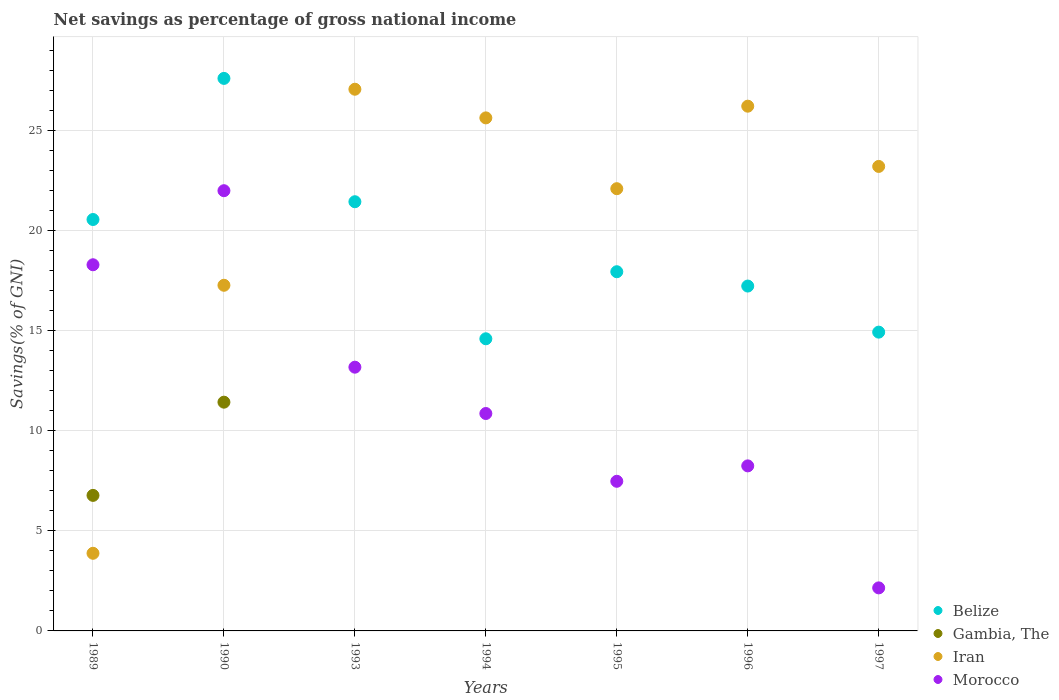What is the total savings in Gambia, The in 1994?
Your response must be concise. 0. Across all years, what is the maximum total savings in Gambia, The?
Provide a succinct answer. 11.43. Across all years, what is the minimum total savings in Morocco?
Make the answer very short. 2.15. What is the total total savings in Morocco in the graph?
Offer a terse response. 82.23. What is the difference between the total savings in Morocco in 1993 and that in 1995?
Provide a succinct answer. 5.7. What is the difference between the total savings in Morocco in 1993 and the total savings in Belize in 1994?
Make the answer very short. -1.42. What is the average total savings in Morocco per year?
Ensure brevity in your answer.  11.75. In the year 1993, what is the difference between the total savings in Iran and total savings in Morocco?
Your response must be concise. 13.89. What is the ratio of the total savings in Gambia, The in 1989 to that in 1990?
Keep it short and to the point. 0.59. Is the total savings in Belize in 1994 less than that in 1996?
Your answer should be very brief. Yes. What is the difference between the highest and the second highest total savings in Iran?
Your answer should be compact. 0.85. What is the difference between the highest and the lowest total savings in Gambia, The?
Offer a very short reply. 11.43. In how many years, is the total savings in Belize greater than the average total savings in Belize taken over all years?
Keep it short and to the point. 3. Is the sum of the total savings in Belize in 1995 and 1997 greater than the maximum total savings in Iran across all years?
Provide a succinct answer. Yes. Is it the case that in every year, the sum of the total savings in Iran and total savings in Gambia, The  is greater than the total savings in Morocco?
Give a very brief answer. No. Is the total savings in Belize strictly greater than the total savings in Gambia, The over the years?
Offer a terse response. Yes. Does the graph contain any zero values?
Ensure brevity in your answer.  Yes. Does the graph contain grids?
Ensure brevity in your answer.  Yes. How many legend labels are there?
Make the answer very short. 4. How are the legend labels stacked?
Your response must be concise. Vertical. What is the title of the graph?
Your answer should be very brief. Net savings as percentage of gross national income. What is the label or title of the X-axis?
Your answer should be very brief. Years. What is the label or title of the Y-axis?
Your response must be concise. Savings(% of GNI). What is the Savings(% of GNI) of Belize in 1989?
Offer a terse response. 20.56. What is the Savings(% of GNI) in Gambia, The in 1989?
Provide a succinct answer. 6.77. What is the Savings(% of GNI) of Iran in 1989?
Offer a very short reply. 3.88. What is the Savings(% of GNI) in Morocco in 1989?
Your answer should be very brief. 18.3. What is the Savings(% of GNI) in Belize in 1990?
Give a very brief answer. 27.61. What is the Savings(% of GNI) of Gambia, The in 1990?
Ensure brevity in your answer.  11.43. What is the Savings(% of GNI) of Iran in 1990?
Your answer should be very brief. 17.28. What is the Savings(% of GNI) of Morocco in 1990?
Your answer should be very brief. 22. What is the Savings(% of GNI) of Belize in 1993?
Ensure brevity in your answer.  21.45. What is the Savings(% of GNI) in Gambia, The in 1993?
Provide a short and direct response. 0. What is the Savings(% of GNI) of Iran in 1993?
Offer a terse response. 27.07. What is the Savings(% of GNI) of Morocco in 1993?
Provide a succinct answer. 13.18. What is the Savings(% of GNI) of Belize in 1994?
Your answer should be very brief. 14.6. What is the Savings(% of GNI) in Gambia, The in 1994?
Ensure brevity in your answer.  0. What is the Savings(% of GNI) in Iran in 1994?
Ensure brevity in your answer.  25.64. What is the Savings(% of GNI) of Morocco in 1994?
Your answer should be compact. 10.87. What is the Savings(% of GNI) of Belize in 1995?
Your response must be concise. 17.95. What is the Savings(% of GNI) of Iran in 1995?
Your answer should be very brief. 22.1. What is the Savings(% of GNI) in Morocco in 1995?
Provide a short and direct response. 7.48. What is the Savings(% of GNI) of Belize in 1996?
Offer a terse response. 17.24. What is the Savings(% of GNI) of Gambia, The in 1996?
Make the answer very short. 0. What is the Savings(% of GNI) in Iran in 1996?
Provide a short and direct response. 26.23. What is the Savings(% of GNI) of Morocco in 1996?
Provide a succinct answer. 8.25. What is the Savings(% of GNI) of Belize in 1997?
Give a very brief answer. 14.93. What is the Savings(% of GNI) in Gambia, The in 1997?
Your answer should be compact. 0. What is the Savings(% of GNI) of Iran in 1997?
Your answer should be compact. 23.21. What is the Savings(% of GNI) in Morocco in 1997?
Provide a succinct answer. 2.15. Across all years, what is the maximum Savings(% of GNI) in Belize?
Offer a very short reply. 27.61. Across all years, what is the maximum Savings(% of GNI) of Gambia, The?
Keep it short and to the point. 11.43. Across all years, what is the maximum Savings(% of GNI) in Iran?
Your response must be concise. 27.07. Across all years, what is the maximum Savings(% of GNI) of Morocco?
Give a very brief answer. 22. Across all years, what is the minimum Savings(% of GNI) in Belize?
Give a very brief answer. 14.6. Across all years, what is the minimum Savings(% of GNI) of Iran?
Keep it short and to the point. 3.88. Across all years, what is the minimum Savings(% of GNI) in Morocco?
Provide a succinct answer. 2.15. What is the total Savings(% of GNI) of Belize in the graph?
Provide a short and direct response. 134.35. What is the total Savings(% of GNI) in Gambia, The in the graph?
Your response must be concise. 18.21. What is the total Savings(% of GNI) in Iran in the graph?
Your answer should be compact. 145.41. What is the total Savings(% of GNI) of Morocco in the graph?
Offer a very short reply. 82.23. What is the difference between the Savings(% of GNI) of Belize in 1989 and that in 1990?
Give a very brief answer. -7.05. What is the difference between the Savings(% of GNI) of Gambia, The in 1989 and that in 1990?
Give a very brief answer. -4.66. What is the difference between the Savings(% of GNI) in Iran in 1989 and that in 1990?
Make the answer very short. -13.4. What is the difference between the Savings(% of GNI) in Morocco in 1989 and that in 1990?
Provide a succinct answer. -3.7. What is the difference between the Savings(% of GNI) of Belize in 1989 and that in 1993?
Ensure brevity in your answer.  -0.89. What is the difference between the Savings(% of GNI) in Iran in 1989 and that in 1993?
Make the answer very short. -23.19. What is the difference between the Savings(% of GNI) in Morocco in 1989 and that in 1993?
Your response must be concise. 5.12. What is the difference between the Savings(% of GNI) in Belize in 1989 and that in 1994?
Your answer should be compact. 5.96. What is the difference between the Savings(% of GNI) in Iran in 1989 and that in 1994?
Give a very brief answer. -21.76. What is the difference between the Savings(% of GNI) of Morocco in 1989 and that in 1994?
Keep it short and to the point. 7.43. What is the difference between the Savings(% of GNI) of Belize in 1989 and that in 1995?
Offer a terse response. 2.61. What is the difference between the Savings(% of GNI) of Iran in 1989 and that in 1995?
Offer a very short reply. -18.22. What is the difference between the Savings(% of GNI) of Morocco in 1989 and that in 1995?
Ensure brevity in your answer.  10.82. What is the difference between the Savings(% of GNI) in Belize in 1989 and that in 1996?
Make the answer very short. 3.33. What is the difference between the Savings(% of GNI) of Iran in 1989 and that in 1996?
Your response must be concise. -22.35. What is the difference between the Savings(% of GNI) in Morocco in 1989 and that in 1996?
Your response must be concise. 10.05. What is the difference between the Savings(% of GNI) of Belize in 1989 and that in 1997?
Offer a terse response. 5.63. What is the difference between the Savings(% of GNI) in Iran in 1989 and that in 1997?
Make the answer very short. -19.34. What is the difference between the Savings(% of GNI) in Morocco in 1989 and that in 1997?
Provide a short and direct response. 16.15. What is the difference between the Savings(% of GNI) in Belize in 1990 and that in 1993?
Ensure brevity in your answer.  6.16. What is the difference between the Savings(% of GNI) in Iran in 1990 and that in 1993?
Give a very brief answer. -9.8. What is the difference between the Savings(% of GNI) in Morocco in 1990 and that in 1993?
Your answer should be compact. 8.82. What is the difference between the Savings(% of GNI) in Belize in 1990 and that in 1994?
Provide a short and direct response. 13.01. What is the difference between the Savings(% of GNI) of Iran in 1990 and that in 1994?
Ensure brevity in your answer.  -8.37. What is the difference between the Savings(% of GNI) of Morocco in 1990 and that in 1994?
Your answer should be very brief. 11.14. What is the difference between the Savings(% of GNI) of Belize in 1990 and that in 1995?
Keep it short and to the point. 9.66. What is the difference between the Savings(% of GNI) in Iran in 1990 and that in 1995?
Provide a succinct answer. -4.83. What is the difference between the Savings(% of GNI) in Morocco in 1990 and that in 1995?
Keep it short and to the point. 14.52. What is the difference between the Savings(% of GNI) in Belize in 1990 and that in 1996?
Offer a terse response. 10.38. What is the difference between the Savings(% of GNI) of Iran in 1990 and that in 1996?
Give a very brief answer. -8.95. What is the difference between the Savings(% of GNI) in Morocco in 1990 and that in 1996?
Offer a terse response. 13.75. What is the difference between the Savings(% of GNI) in Belize in 1990 and that in 1997?
Offer a very short reply. 12.68. What is the difference between the Savings(% of GNI) in Iran in 1990 and that in 1997?
Your answer should be very brief. -5.94. What is the difference between the Savings(% of GNI) of Morocco in 1990 and that in 1997?
Give a very brief answer. 19.85. What is the difference between the Savings(% of GNI) of Belize in 1993 and that in 1994?
Your answer should be very brief. 6.85. What is the difference between the Savings(% of GNI) of Iran in 1993 and that in 1994?
Offer a terse response. 1.43. What is the difference between the Savings(% of GNI) of Morocco in 1993 and that in 1994?
Offer a very short reply. 2.32. What is the difference between the Savings(% of GNI) in Belize in 1993 and that in 1995?
Offer a terse response. 3.5. What is the difference between the Savings(% of GNI) in Iran in 1993 and that in 1995?
Make the answer very short. 4.97. What is the difference between the Savings(% of GNI) in Morocco in 1993 and that in 1995?
Offer a very short reply. 5.7. What is the difference between the Savings(% of GNI) of Belize in 1993 and that in 1996?
Your answer should be very brief. 4.21. What is the difference between the Savings(% of GNI) of Iran in 1993 and that in 1996?
Give a very brief answer. 0.85. What is the difference between the Savings(% of GNI) of Morocco in 1993 and that in 1996?
Give a very brief answer. 4.93. What is the difference between the Savings(% of GNI) in Belize in 1993 and that in 1997?
Your answer should be compact. 6.52. What is the difference between the Savings(% of GNI) of Iran in 1993 and that in 1997?
Ensure brevity in your answer.  3.86. What is the difference between the Savings(% of GNI) of Morocco in 1993 and that in 1997?
Your answer should be very brief. 11.03. What is the difference between the Savings(% of GNI) in Belize in 1994 and that in 1995?
Offer a terse response. -3.35. What is the difference between the Savings(% of GNI) in Iran in 1994 and that in 1995?
Keep it short and to the point. 3.54. What is the difference between the Savings(% of GNI) in Morocco in 1994 and that in 1995?
Ensure brevity in your answer.  3.39. What is the difference between the Savings(% of GNI) in Belize in 1994 and that in 1996?
Your answer should be very brief. -2.64. What is the difference between the Savings(% of GNI) of Iran in 1994 and that in 1996?
Your answer should be compact. -0.58. What is the difference between the Savings(% of GNI) in Morocco in 1994 and that in 1996?
Your answer should be compact. 2.62. What is the difference between the Savings(% of GNI) in Belize in 1994 and that in 1997?
Ensure brevity in your answer.  -0.33. What is the difference between the Savings(% of GNI) of Iran in 1994 and that in 1997?
Your answer should be very brief. 2.43. What is the difference between the Savings(% of GNI) of Morocco in 1994 and that in 1997?
Your response must be concise. 8.71. What is the difference between the Savings(% of GNI) of Belize in 1995 and that in 1996?
Ensure brevity in your answer.  0.72. What is the difference between the Savings(% of GNI) of Iran in 1995 and that in 1996?
Make the answer very short. -4.12. What is the difference between the Savings(% of GNI) in Morocco in 1995 and that in 1996?
Your response must be concise. -0.77. What is the difference between the Savings(% of GNI) of Belize in 1995 and that in 1997?
Ensure brevity in your answer.  3.02. What is the difference between the Savings(% of GNI) in Iran in 1995 and that in 1997?
Offer a very short reply. -1.11. What is the difference between the Savings(% of GNI) in Morocco in 1995 and that in 1997?
Give a very brief answer. 5.33. What is the difference between the Savings(% of GNI) of Belize in 1996 and that in 1997?
Provide a succinct answer. 2.3. What is the difference between the Savings(% of GNI) in Iran in 1996 and that in 1997?
Ensure brevity in your answer.  3.01. What is the difference between the Savings(% of GNI) in Morocco in 1996 and that in 1997?
Your response must be concise. 6.1. What is the difference between the Savings(% of GNI) of Belize in 1989 and the Savings(% of GNI) of Gambia, The in 1990?
Offer a very short reply. 9.13. What is the difference between the Savings(% of GNI) in Belize in 1989 and the Savings(% of GNI) in Iran in 1990?
Offer a terse response. 3.29. What is the difference between the Savings(% of GNI) of Belize in 1989 and the Savings(% of GNI) of Morocco in 1990?
Give a very brief answer. -1.44. What is the difference between the Savings(% of GNI) in Gambia, The in 1989 and the Savings(% of GNI) in Iran in 1990?
Keep it short and to the point. -10.5. What is the difference between the Savings(% of GNI) in Gambia, The in 1989 and the Savings(% of GNI) in Morocco in 1990?
Keep it short and to the point. -15.23. What is the difference between the Savings(% of GNI) in Iran in 1989 and the Savings(% of GNI) in Morocco in 1990?
Your response must be concise. -18.12. What is the difference between the Savings(% of GNI) in Belize in 1989 and the Savings(% of GNI) in Iran in 1993?
Provide a succinct answer. -6.51. What is the difference between the Savings(% of GNI) in Belize in 1989 and the Savings(% of GNI) in Morocco in 1993?
Give a very brief answer. 7.38. What is the difference between the Savings(% of GNI) in Gambia, The in 1989 and the Savings(% of GNI) in Iran in 1993?
Your answer should be compact. -20.3. What is the difference between the Savings(% of GNI) in Gambia, The in 1989 and the Savings(% of GNI) in Morocco in 1993?
Give a very brief answer. -6.41. What is the difference between the Savings(% of GNI) in Iran in 1989 and the Savings(% of GNI) in Morocco in 1993?
Offer a terse response. -9.3. What is the difference between the Savings(% of GNI) of Belize in 1989 and the Savings(% of GNI) of Iran in 1994?
Provide a short and direct response. -5.08. What is the difference between the Savings(% of GNI) in Belize in 1989 and the Savings(% of GNI) in Morocco in 1994?
Ensure brevity in your answer.  9.7. What is the difference between the Savings(% of GNI) in Gambia, The in 1989 and the Savings(% of GNI) in Iran in 1994?
Make the answer very short. -18.87. What is the difference between the Savings(% of GNI) in Gambia, The in 1989 and the Savings(% of GNI) in Morocco in 1994?
Provide a succinct answer. -4.09. What is the difference between the Savings(% of GNI) of Iran in 1989 and the Savings(% of GNI) of Morocco in 1994?
Your response must be concise. -6.99. What is the difference between the Savings(% of GNI) of Belize in 1989 and the Savings(% of GNI) of Iran in 1995?
Your response must be concise. -1.54. What is the difference between the Savings(% of GNI) in Belize in 1989 and the Savings(% of GNI) in Morocco in 1995?
Give a very brief answer. 13.08. What is the difference between the Savings(% of GNI) in Gambia, The in 1989 and the Savings(% of GNI) in Iran in 1995?
Provide a succinct answer. -15.33. What is the difference between the Savings(% of GNI) in Gambia, The in 1989 and the Savings(% of GNI) in Morocco in 1995?
Provide a succinct answer. -0.7. What is the difference between the Savings(% of GNI) in Iran in 1989 and the Savings(% of GNI) in Morocco in 1995?
Give a very brief answer. -3.6. What is the difference between the Savings(% of GNI) of Belize in 1989 and the Savings(% of GNI) of Iran in 1996?
Make the answer very short. -5.66. What is the difference between the Savings(% of GNI) of Belize in 1989 and the Savings(% of GNI) of Morocco in 1996?
Your answer should be very brief. 12.31. What is the difference between the Savings(% of GNI) of Gambia, The in 1989 and the Savings(% of GNI) of Iran in 1996?
Your response must be concise. -19.45. What is the difference between the Savings(% of GNI) in Gambia, The in 1989 and the Savings(% of GNI) in Morocco in 1996?
Your response must be concise. -1.47. What is the difference between the Savings(% of GNI) in Iran in 1989 and the Savings(% of GNI) in Morocco in 1996?
Keep it short and to the point. -4.37. What is the difference between the Savings(% of GNI) in Belize in 1989 and the Savings(% of GNI) in Iran in 1997?
Offer a very short reply. -2.65. What is the difference between the Savings(% of GNI) in Belize in 1989 and the Savings(% of GNI) in Morocco in 1997?
Make the answer very short. 18.41. What is the difference between the Savings(% of GNI) in Gambia, The in 1989 and the Savings(% of GNI) in Iran in 1997?
Provide a short and direct response. -16.44. What is the difference between the Savings(% of GNI) of Gambia, The in 1989 and the Savings(% of GNI) of Morocco in 1997?
Your response must be concise. 4.62. What is the difference between the Savings(% of GNI) of Iran in 1989 and the Savings(% of GNI) of Morocco in 1997?
Give a very brief answer. 1.73. What is the difference between the Savings(% of GNI) of Belize in 1990 and the Savings(% of GNI) of Iran in 1993?
Your answer should be very brief. 0.54. What is the difference between the Savings(% of GNI) of Belize in 1990 and the Savings(% of GNI) of Morocco in 1993?
Provide a short and direct response. 14.43. What is the difference between the Savings(% of GNI) in Gambia, The in 1990 and the Savings(% of GNI) in Iran in 1993?
Offer a very short reply. -15.64. What is the difference between the Savings(% of GNI) of Gambia, The in 1990 and the Savings(% of GNI) of Morocco in 1993?
Provide a short and direct response. -1.75. What is the difference between the Savings(% of GNI) of Iran in 1990 and the Savings(% of GNI) of Morocco in 1993?
Give a very brief answer. 4.09. What is the difference between the Savings(% of GNI) in Belize in 1990 and the Savings(% of GNI) in Iran in 1994?
Keep it short and to the point. 1.97. What is the difference between the Savings(% of GNI) in Belize in 1990 and the Savings(% of GNI) in Morocco in 1994?
Your response must be concise. 16.75. What is the difference between the Savings(% of GNI) in Gambia, The in 1990 and the Savings(% of GNI) in Iran in 1994?
Your answer should be very brief. -14.21. What is the difference between the Savings(% of GNI) of Gambia, The in 1990 and the Savings(% of GNI) of Morocco in 1994?
Offer a very short reply. 0.57. What is the difference between the Savings(% of GNI) in Iran in 1990 and the Savings(% of GNI) in Morocco in 1994?
Your response must be concise. 6.41. What is the difference between the Savings(% of GNI) in Belize in 1990 and the Savings(% of GNI) in Iran in 1995?
Your response must be concise. 5.51. What is the difference between the Savings(% of GNI) in Belize in 1990 and the Savings(% of GNI) in Morocco in 1995?
Provide a short and direct response. 20.14. What is the difference between the Savings(% of GNI) of Gambia, The in 1990 and the Savings(% of GNI) of Iran in 1995?
Make the answer very short. -10.67. What is the difference between the Savings(% of GNI) in Gambia, The in 1990 and the Savings(% of GNI) in Morocco in 1995?
Provide a short and direct response. 3.95. What is the difference between the Savings(% of GNI) of Iran in 1990 and the Savings(% of GNI) of Morocco in 1995?
Offer a very short reply. 9.8. What is the difference between the Savings(% of GNI) of Belize in 1990 and the Savings(% of GNI) of Iran in 1996?
Make the answer very short. 1.39. What is the difference between the Savings(% of GNI) in Belize in 1990 and the Savings(% of GNI) in Morocco in 1996?
Your answer should be very brief. 19.37. What is the difference between the Savings(% of GNI) in Gambia, The in 1990 and the Savings(% of GNI) in Iran in 1996?
Your answer should be very brief. -14.79. What is the difference between the Savings(% of GNI) of Gambia, The in 1990 and the Savings(% of GNI) of Morocco in 1996?
Make the answer very short. 3.18. What is the difference between the Savings(% of GNI) of Iran in 1990 and the Savings(% of GNI) of Morocco in 1996?
Offer a terse response. 9.03. What is the difference between the Savings(% of GNI) of Belize in 1990 and the Savings(% of GNI) of Iran in 1997?
Make the answer very short. 4.4. What is the difference between the Savings(% of GNI) of Belize in 1990 and the Savings(% of GNI) of Morocco in 1997?
Ensure brevity in your answer.  25.46. What is the difference between the Savings(% of GNI) of Gambia, The in 1990 and the Savings(% of GNI) of Iran in 1997?
Your answer should be very brief. -11.78. What is the difference between the Savings(% of GNI) in Gambia, The in 1990 and the Savings(% of GNI) in Morocco in 1997?
Your answer should be compact. 9.28. What is the difference between the Savings(% of GNI) of Iran in 1990 and the Savings(% of GNI) of Morocco in 1997?
Offer a very short reply. 15.12. What is the difference between the Savings(% of GNI) of Belize in 1993 and the Savings(% of GNI) of Iran in 1994?
Your answer should be very brief. -4.19. What is the difference between the Savings(% of GNI) in Belize in 1993 and the Savings(% of GNI) in Morocco in 1994?
Offer a very short reply. 10.58. What is the difference between the Savings(% of GNI) of Iran in 1993 and the Savings(% of GNI) of Morocco in 1994?
Give a very brief answer. 16.21. What is the difference between the Savings(% of GNI) in Belize in 1993 and the Savings(% of GNI) in Iran in 1995?
Give a very brief answer. -0.65. What is the difference between the Savings(% of GNI) of Belize in 1993 and the Savings(% of GNI) of Morocco in 1995?
Offer a terse response. 13.97. What is the difference between the Savings(% of GNI) of Iran in 1993 and the Savings(% of GNI) of Morocco in 1995?
Provide a short and direct response. 19.59. What is the difference between the Savings(% of GNI) in Belize in 1993 and the Savings(% of GNI) in Iran in 1996?
Keep it short and to the point. -4.78. What is the difference between the Savings(% of GNI) of Belize in 1993 and the Savings(% of GNI) of Morocco in 1996?
Ensure brevity in your answer.  13.2. What is the difference between the Savings(% of GNI) of Iran in 1993 and the Savings(% of GNI) of Morocco in 1996?
Ensure brevity in your answer.  18.82. What is the difference between the Savings(% of GNI) of Belize in 1993 and the Savings(% of GNI) of Iran in 1997?
Keep it short and to the point. -1.76. What is the difference between the Savings(% of GNI) in Belize in 1993 and the Savings(% of GNI) in Morocco in 1997?
Give a very brief answer. 19.3. What is the difference between the Savings(% of GNI) in Iran in 1993 and the Savings(% of GNI) in Morocco in 1997?
Provide a short and direct response. 24.92. What is the difference between the Savings(% of GNI) of Belize in 1994 and the Savings(% of GNI) of Iran in 1995?
Your answer should be very brief. -7.5. What is the difference between the Savings(% of GNI) in Belize in 1994 and the Savings(% of GNI) in Morocco in 1995?
Ensure brevity in your answer.  7.12. What is the difference between the Savings(% of GNI) in Iran in 1994 and the Savings(% of GNI) in Morocco in 1995?
Your response must be concise. 18.16. What is the difference between the Savings(% of GNI) in Belize in 1994 and the Savings(% of GNI) in Iran in 1996?
Keep it short and to the point. -11.63. What is the difference between the Savings(% of GNI) of Belize in 1994 and the Savings(% of GNI) of Morocco in 1996?
Offer a terse response. 6.35. What is the difference between the Savings(% of GNI) in Iran in 1994 and the Savings(% of GNI) in Morocco in 1996?
Your response must be concise. 17.39. What is the difference between the Savings(% of GNI) in Belize in 1994 and the Savings(% of GNI) in Iran in 1997?
Ensure brevity in your answer.  -8.61. What is the difference between the Savings(% of GNI) in Belize in 1994 and the Savings(% of GNI) in Morocco in 1997?
Ensure brevity in your answer.  12.45. What is the difference between the Savings(% of GNI) of Iran in 1994 and the Savings(% of GNI) of Morocco in 1997?
Give a very brief answer. 23.49. What is the difference between the Savings(% of GNI) of Belize in 1995 and the Savings(% of GNI) of Iran in 1996?
Provide a short and direct response. -8.27. What is the difference between the Savings(% of GNI) in Belize in 1995 and the Savings(% of GNI) in Morocco in 1996?
Give a very brief answer. 9.7. What is the difference between the Savings(% of GNI) of Iran in 1995 and the Savings(% of GNI) of Morocco in 1996?
Give a very brief answer. 13.85. What is the difference between the Savings(% of GNI) in Belize in 1995 and the Savings(% of GNI) in Iran in 1997?
Offer a very short reply. -5.26. What is the difference between the Savings(% of GNI) of Belize in 1995 and the Savings(% of GNI) of Morocco in 1997?
Your answer should be very brief. 15.8. What is the difference between the Savings(% of GNI) in Iran in 1995 and the Savings(% of GNI) in Morocco in 1997?
Provide a short and direct response. 19.95. What is the difference between the Savings(% of GNI) in Belize in 1996 and the Savings(% of GNI) in Iran in 1997?
Ensure brevity in your answer.  -5.98. What is the difference between the Savings(% of GNI) in Belize in 1996 and the Savings(% of GNI) in Morocco in 1997?
Ensure brevity in your answer.  15.09. What is the difference between the Savings(% of GNI) of Iran in 1996 and the Savings(% of GNI) of Morocco in 1997?
Your answer should be compact. 24.07. What is the average Savings(% of GNI) of Belize per year?
Provide a short and direct response. 19.19. What is the average Savings(% of GNI) in Gambia, The per year?
Provide a succinct answer. 2.6. What is the average Savings(% of GNI) in Iran per year?
Provide a succinct answer. 20.77. What is the average Savings(% of GNI) of Morocco per year?
Give a very brief answer. 11.75. In the year 1989, what is the difference between the Savings(% of GNI) of Belize and Savings(% of GNI) of Gambia, The?
Offer a very short reply. 13.79. In the year 1989, what is the difference between the Savings(% of GNI) in Belize and Savings(% of GNI) in Iran?
Provide a short and direct response. 16.68. In the year 1989, what is the difference between the Savings(% of GNI) of Belize and Savings(% of GNI) of Morocco?
Your response must be concise. 2.26. In the year 1989, what is the difference between the Savings(% of GNI) of Gambia, The and Savings(% of GNI) of Iran?
Your answer should be compact. 2.89. In the year 1989, what is the difference between the Savings(% of GNI) in Gambia, The and Savings(% of GNI) in Morocco?
Your answer should be very brief. -11.53. In the year 1989, what is the difference between the Savings(% of GNI) in Iran and Savings(% of GNI) in Morocco?
Your answer should be very brief. -14.42. In the year 1990, what is the difference between the Savings(% of GNI) in Belize and Savings(% of GNI) in Gambia, The?
Offer a terse response. 16.18. In the year 1990, what is the difference between the Savings(% of GNI) of Belize and Savings(% of GNI) of Iran?
Provide a short and direct response. 10.34. In the year 1990, what is the difference between the Savings(% of GNI) of Belize and Savings(% of GNI) of Morocco?
Keep it short and to the point. 5.61. In the year 1990, what is the difference between the Savings(% of GNI) of Gambia, The and Savings(% of GNI) of Iran?
Your response must be concise. -5.84. In the year 1990, what is the difference between the Savings(% of GNI) in Gambia, The and Savings(% of GNI) in Morocco?
Provide a succinct answer. -10.57. In the year 1990, what is the difference between the Savings(% of GNI) in Iran and Savings(% of GNI) in Morocco?
Keep it short and to the point. -4.73. In the year 1993, what is the difference between the Savings(% of GNI) in Belize and Savings(% of GNI) in Iran?
Keep it short and to the point. -5.62. In the year 1993, what is the difference between the Savings(% of GNI) of Belize and Savings(% of GNI) of Morocco?
Keep it short and to the point. 8.27. In the year 1993, what is the difference between the Savings(% of GNI) in Iran and Savings(% of GNI) in Morocco?
Your answer should be compact. 13.89. In the year 1994, what is the difference between the Savings(% of GNI) in Belize and Savings(% of GNI) in Iran?
Provide a succinct answer. -11.04. In the year 1994, what is the difference between the Savings(% of GNI) in Belize and Savings(% of GNI) in Morocco?
Ensure brevity in your answer.  3.73. In the year 1994, what is the difference between the Savings(% of GNI) of Iran and Savings(% of GNI) of Morocco?
Your answer should be very brief. 14.78. In the year 1995, what is the difference between the Savings(% of GNI) of Belize and Savings(% of GNI) of Iran?
Your response must be concise. -4.15. In the year 1995, what is the difference between the Savings(% of GNI) of Belize and Savings(% of GNI) of Morocco?
Offer a terse response. 10.47. In the year 1995, what is the difference between the Savings(% of GNI) of Iran and Savings(% of GNI) of Morocco?
Provide a short and direct response. 14.62. In the year 1996, what is the difference between the Savings(% of GNI) in Belize and Savings(% of GNI) in Iran?
Offer a very short reply. -8.99. In the year 1996, what is the difference between the Savings(% of GNI) in Belize and Savings(% of GNI) in Morocco?
Your response must be concise. 8.99. In the year 1996, what is the difference between the Savings(% of GNI) of Iran and Savings(% of GNI) of Morocco?
Make the answer very short. 17.98. In the year 1997, what is the difference between the Savings(% of GNI) in Belize and Savings(% of GNI) in Iran?
Keep it short and to the point. -8.28. In the year 1997, what is the difference between the Savings(% of GNI) of Belize and Savings(% of GNI) of Morocco?
Keep it short and to the point. 12.78. In the year 1997, what is the difference between the Savings(% of GNI) of Iran and Savings(% of GNI) of Morocco?
Offer a very short reply. 21.06. What is the ratio of the Savings(% of GNI) in Belize in 1989 to that in 1990?
Your response must be concise. 0.74. What is the ratio of the Savings(% of GNI) in Gambia, The in 1989 to that in 1990?
Offer a terse response. 0.59. What is the ratio of the Savings(% of GNI) of Iran in 1989 to that in 1990?
Provide a succinct answer. 0.22. What is the ratio of the Savings(% of GNI) of Morocco in 1989 to that in 1990?
Offer a very short reply. 0.83. What is the ratio of the Savings(% of GNI) in Belize in 1989 to that in 1993?
Your answer should be very brief. 0.96. What is the ratio of the Savings(% of GNI) in Iran in 1989 to that in 1993?
Your answer should be compact. 0.14. What is the ratio of the Savings(% of GNI) of Morocco in 1989 to that in 1993?
Offer a very short reply. 1.39. What is the ratio of the Savings(% of GNI) in Belize in 1989 to that in 1994?
Ensure brevity in your answer.  1.41. What is the ratio of the Savings(% of GNI) of Iran in 1989 to that in 1994?
Provide a succinct answer. 0.15. What is the ratio of the Savings(% of GNI) of Morocco in 1989 to that in 1994?
Ensure brevity in your answer.  1.68. What is the ratio of the Savings(% of GNI) of Belize in 1989 to that in 1995?
Keep it short and to the point. 1.15. What is the ratio of the Savings(% of GNI) in Iran in 1989 to that in 1995?
Offer a very short reply. 0.18. What is the ratio of the Savings(% of GNI) of Morocco in 1989 to that in 1995?
Your response must be concise. 2.45. What is the ratio of the Savings(% of GNI) in Belize in 1989 to that in 1996?
Offer a terse response. 1.19. What is the ratio of the Savings(% of GNI) of Iran in 1989 to that in 1996?
Your response must be concise. 0.15. What is the ratio of the Savings(% of GNI) of Morocco in 1989 to that in 1996?
Your answer should be very brief. 2.22. What is the ratio of the Savings(% of GNI) of Belize in 1989 to that in 1997?
Your answer should be compact. 1.38. What is the ratio of the Savings(% of GNI) of Iran in 1989 to that in 1997?
Keep it short and to the point. 0.17. What is the ratio of the Savings(% of GNI) in Morocco in 1989 to that in 1997?
Give a very brief answer. 8.51. What is the ratio of the Savings(% of GNI) in Belize in 1990 to that in 1993?
Your response must be concise. 1.29. What is the ratio of the Savings(% of GNI) of Iran in 1990 to that in 1993?
Ensure brevity in your answer.  0.64. What is the ratio of the Savings(% of GNI) in Morocco in 1990 to that in 1993?
Make the answer very short. 1.67. What is the ratio of the Savings(% of GNI) in Belize in 1990 to that in 1994?
Offer a terse response. 1.89. What is the ratio of the Savings(% of GNI) in Iran in 1990 to that in 1994?
Offer a very short reply. 0.67. What is the ratio of the Savings(% of GNI) of Morocco in 1990 to that in 1994?
Keep it short and to the point. 2.02. What is the ratio of the Savings(% of GNI) of Belize in 1990 to that in 1995?
Ensure brevity in your answer.  1.54. What is the ratio of the Savings(% of GNI) in Iran in 1990 to that in 1995?
Your response must be concise. 0.78. What is the ratio of the Savings(% of GNI) in Morocco in 1990 to that in 1995?
Ensure brevity in your answer.  2.94. What is the ratio of the Savings(% of GNI) of Belize in 1990 to that in 1996?
Your response must be concise. 1.6. What is the ratio of the Savings(% of GNI) in Iran in 1990 to that in 1996?
Offer a terse response. 0.66. What is the ratio of the Savings(% of GNI) in Morocco in 1990 to that in 1996?
Make the answer very short. 2.67. What is the ratio of the Savings(% of GNI) of Belize in 1990 to that in 1997?
Give a very brief answer. 1.85. What is the ratio of the Savings(% of GNI) of Iran in 1990 to that in 1997?
Provide a short and direct response. 0.74. What is the ratio of the Savings(% of GNI) of Morocco in 1990 to that in 1997?
Give a very brief answer. 10.23. What is the ratio of the Savings(% of GNI) of Belize in 1993 to that in 1994?
Offer a very short reply. 1.47. What is the ratio of the Savings(% of GNI) of Iran in 1993 to that in 1994?
Your response must be concise. 1.06. What is the ratio of the Savings(% of GNI) in Morocco in 1993 to that in 1994?
Provide a short and direct response. 1.21. What is the ratio of the Savings(% of GNI) in Belize in 1993 to that in 1995?
Ensure brevity in your answer.  1.19. What is the ratio of the Savings(% of GNI) of Iran in 1993 to that in 1995?
Your answer should be compact. 1.22. What is the ratio of the Savings(% of GNI) of Morocco in 1993 to that in 1995?
Give a very brief answer. 1.76. What is the ratio of the Savings(% of GNI) of Belize in 1993 to that in 1996?
Provide a short and direct response. 1.24. What is the ratio of the Savings(% of GNI) of Iran in 1993 to that in 1996?
Ensure brevity in your answer.  1.03. What is the ratio of the Savings(% of GNI) in Morocco in 1993 to that in 1996?
Offer a very short reply. 1.6. What is the ratio of the Savings(% of GNI) of Belize in 1993 to that in 1997?
Offer a very short reply. 1.44. What is the ratio of the Savings(% of GNI) of Iran in 1993 to that in 1997?
Ensure brevity in your answer.  1.17. What is the ratio of the Savings(% of GNI) of Morocco in 1993 to that in 1997?
Your answer should be very brief. 6.13. What is the ratio of the Savings(% of GNI) of Belize in 1994 to that in 1995?
Provide a succinct answer. 0.81. What is the ratio of the Savings(% of GNI) of Iran in 1994 to that in 1995?
Ensure brevity in your answer.  1.16. What is the ratio of the Savings(% of GNI) in Morocco in 1994 to that in 1995?
Give a very brief answer. 1.45. What is the ratio of the Savings(% of GNI) of Belize in 1994 to that in 1996?
Make the answer very short. 0.85. What is the ratio of the Savings(% of GNI) of Iran in 1994 to that in 1996?
Your answer should be very brief. 0.98. What is the ratio of the Savings(% of GNI) in Morocco in 1994 to that in 1996?
Your answer should be compact. 1.32. What is the ratio of the Savings(% of GNI) in Belize in 1994 to that in 1997?
Your response must be concise. 0.98. What is the ratio of the Savings(% of GNI) in Iran in 1994 to that in 1997?
Your answer should be very brief. 1.1. What is the ratio of the Savings(% of GNI) of Morocco in 1994 to that in 1997?
Offer a terse response. 5.05. What is the ratio of the Savings(% of GNI) of Belize in 1995 to that in 1996?
Your answer should be compact. 1.04. What is the ratio of the Savings(% of GNI) of Iran in 1995 to that in 1996?
Offer a terse response. 0.84. What is the ratio of the Savings(% of GNI) of Morocco in 1995 to that in 1996?
Provide a succinct answer. 0.91. What is the ratio of the Savings(% of GNI) of Belize in 1995 to that in 1997?
Your answer should be very brief. 1.2. What is the ratio of the Savings(% of GNI) of Iran in 1995 to that in 1997?
Provide a succinct answer. 0.95. What is the ratio of the Savings(% of GNI) of Morocco in 1995 to that in 1997?
Provide a succinct answer. 3.48. What is the ratio of the Savings(% of GNI) in Belize in 1996 to that in 1997?
Make the answer very short. 1.15. What is the ratio of the Savings(% of GNI) of Iran in 1996 to that in 1997?
Your response must be concise. 1.13. What is the ratio of the Savings(% of GNI) of Morocco in 1996 to that in 1997?
Your answer should be very brief. 3.83. What is the difference between the highest and the second highest Savings(% of GNI) of Belize?
Make the answer very short. 6.16. What is the difference between the highest and the second highest Savings(% of GNI) of Iran?
Provide a short and direct response. 0.85. What is the difference between the highest and the second highest Savings(% of GNI) in Morocco?
Make the answer very short. 3.7. What is the difference between the highest and the lowest Savings(% of GNI) in Belize?
Your answer should be compact. 13.01. What is the difference between the highest and the lowest Savings(% of GNI) of Gambia, The?
Make the answer very short. 11.43. What is the difference between the highest and the lowest Savings(% of GNI) in Iran?
Provide a short and direct response. 23.19. What is the difference between the highest and the lowest Savings(% of GNI) of Morocco?
Provide a succinct answer. 19.85. 